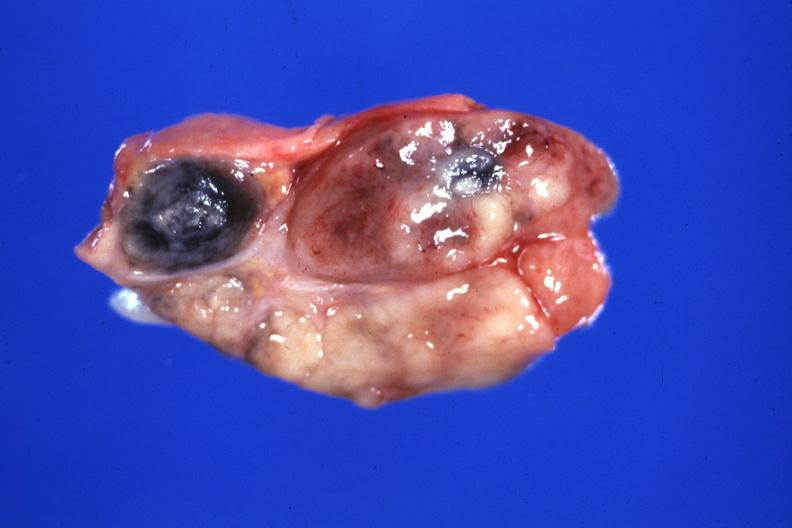s sarcoidosis present?
Answer the question using a single word or phrase. Yes 